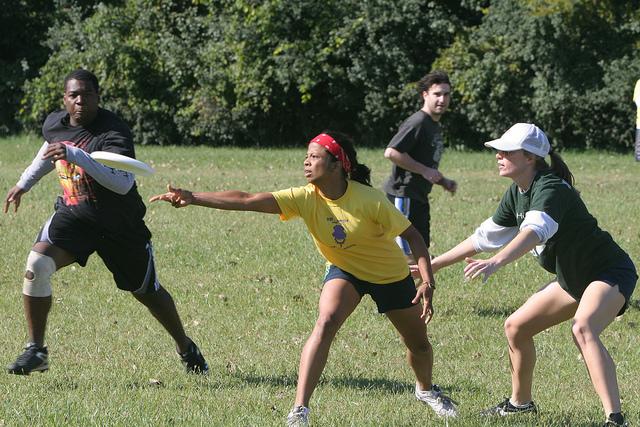What color is the woman's headband?
Be succinct. Red. What sport are they playing?
Concise answer only. Frisbee. How many people are there?
Concise answer only. 4. 